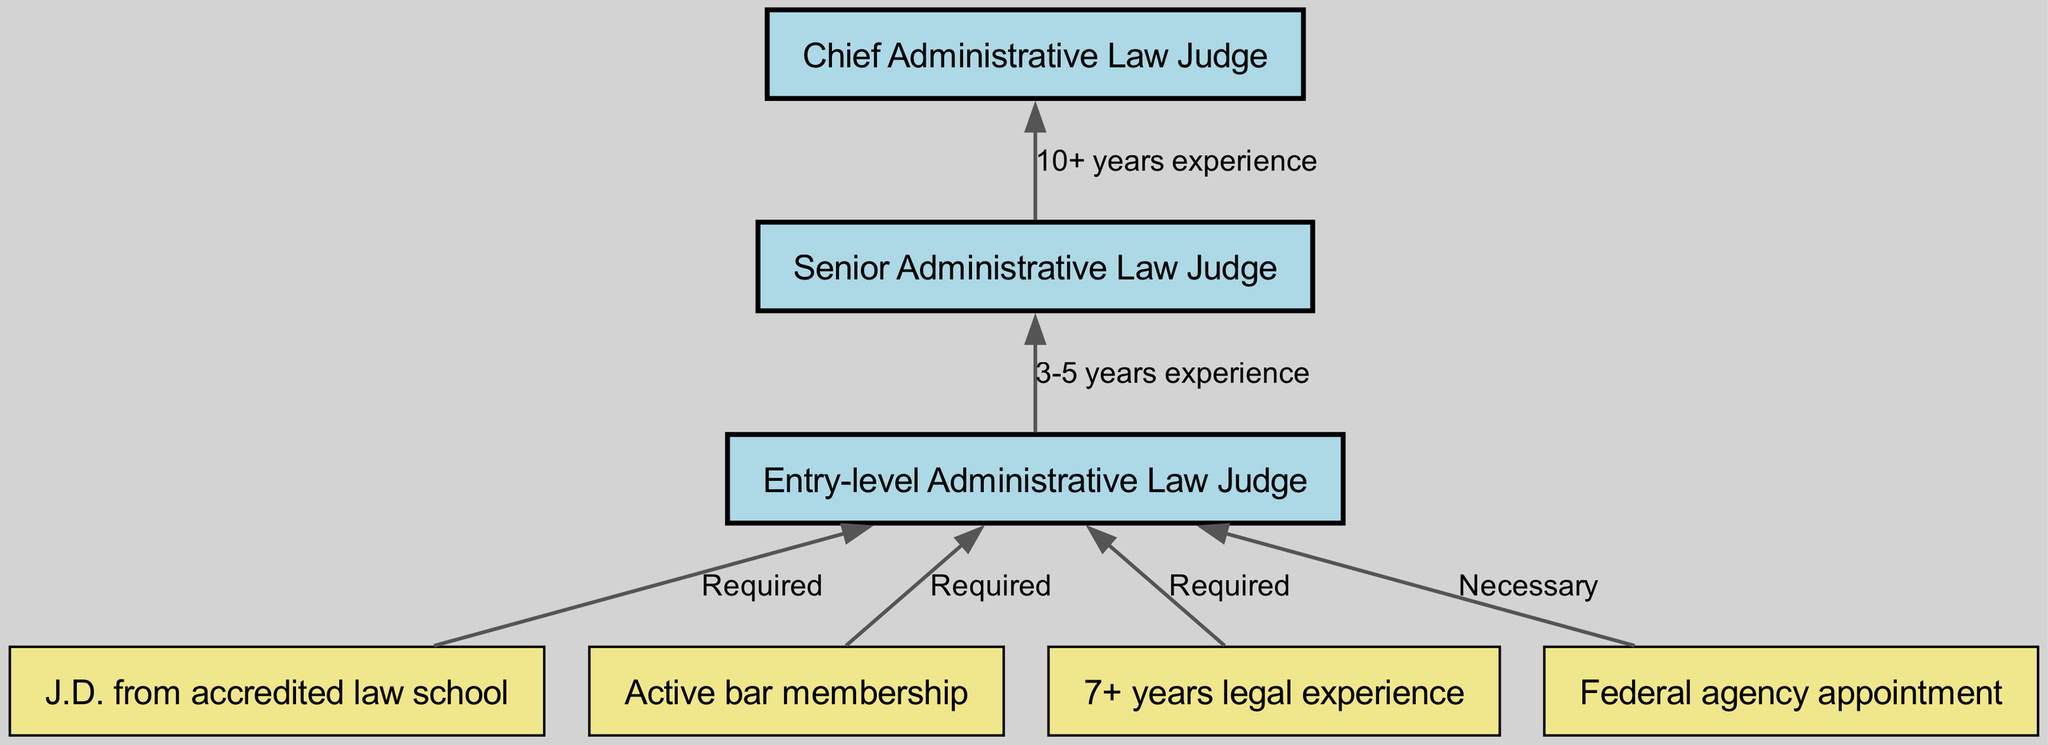What is the entry-level position in the career progression? The diagram specifies that the "Entry-level Administrative Law Judge" is the first position listed for career entry. It is the starting point in the flow.
Answer: Entry-level Administrative Law Judge How many years of legal experience are required for an entry-level position? The diagram states that "7+ years legal experience" is required to qualify for the entry-level Administrative Law Judge position, indicating a level of experience necessary before applying.
Answer: 7+ years legal experience What is the pathway from an entry-level judge to a senior judge? The diagram shows an arrow from the "Entry-level Administrative Law Judge" to "Senior Administrative Law Judge" with a note describing "3-5 years experience," indicating this is needed for progression to the next level.
Answer: 3-5 years experience What is needed for a federal agency appointment? The diagram indicates that a "Federal agency appointment" is listed as a necessary requirement for entering the career as an Administrative Law Judge, found directly connected to the entry-level position.
Answer: Necessary What is the maximum number of years of experience one might require to become a Chief Administrative Law Judge? According to the flow chart, transitioning from Senior Administrative Law Judge to Chief requires "10+ years experience," and combined with the previous levels, one could infer an extensive career requirement. However, estimating the maximum would require a conservative addition of "3-5" and "10+", bringing it to around 13-15 years total if one considers a linear progression.
Answer: 10+ years experience What type of law degree is necessary for the entry-level position? The diagram specifies that a "J.D. from accredited law school" is required for the entry-level Administrative Law Judge position, indicating a fundamental educational requirement.
Answer: J.D. from accredited law school Which position requires the most experience based on the diagram? The diagram shows that the "Chief Administrative Law Judge" position requires "10+ years experience," which is the highest among the positions listed. This indicates it is the most senior position requiring substantial experience.
Answer: Chief Administrative Law Judge How many nodes describe the qualifications needed for the entry-level role? The diagram lists three qualifications that are necessary for the entry-level Administrative Law Judge position: "J.D. from accredited law school," "Active bar membership," and "7+ years legal experience." Therefore, it contains a total of three qualification nodes leading into it.
Answer: 3 What is the relationship between a Senior Administrative Law Judge and a Chief Administrative Law Judge? The diagram shows a direct connection from "Senior Administrative Law Judge" to "Chief Administrative Law Judge" with the note saying "10+ years experience," indicating a clear pathway by which one moves up to the highest role, highlighting that a senior judge needs significant further experience in order to advance.
Answer: 10+ years experience 